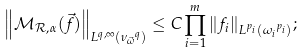<formula> <loc_0><loc_0><loc_500><loc_500>{ \left \| \mathcal { M } _ { \mathcal { R } , \alpha } ( \vec { f } ) \right \| } _ { L ^ { q , \infty } ( { \nu _ { \vec { \omega } } } ^ { q } ) } \leq C \prod _ { i = 1 } ^ { m } { \left \| f _ { i } \right \| } _ { L ^ { p _ { i } } ( { \omega _ { i } } ^ { p _ { i } } ) } ;</formula> 